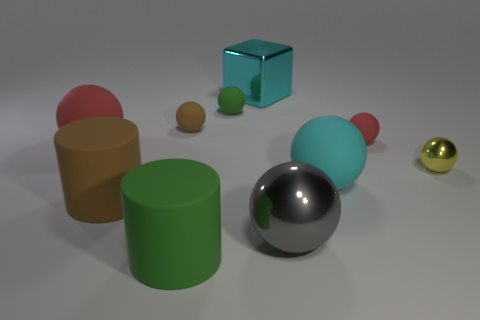Subtract all tiny red rubber spheres. How many spheres are left? 6 Subtract all red balls. How many balls are left? 5 Subtract 2 spheres. How many spheres are left? 5 Add 1 yellow metal things. How many yellow metal things exist? 2 Subtract 1 green cylinders. How many objects are left? 9 Subtract all cylinders. How many objects are left? 8 Subtract all red blocks. Subtract all blue spheres. How many blocks are left? 1 Subtract all yellow cylinders. How many green cubes are left? 0 Subtract all brown rubber balls. Subtract all tiny brown rubber objects. How many objects are left? 8 Add 1 large shiny blocks. How many large shiny blocks are left? 2 